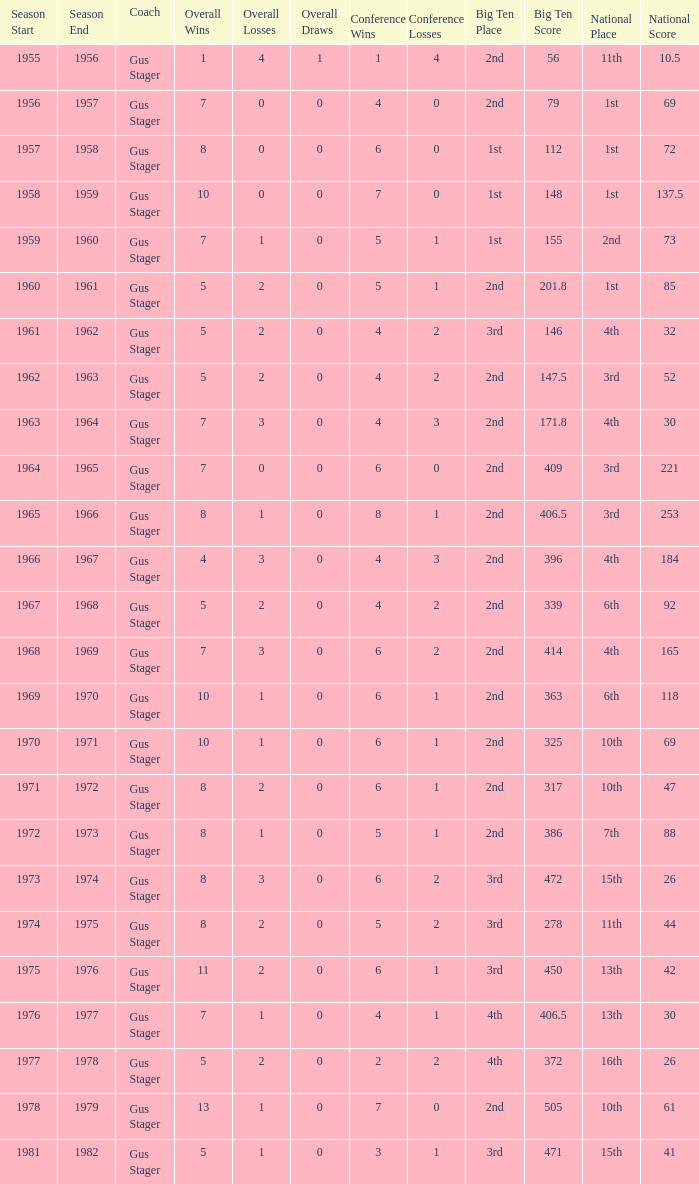What is the Coach with a Big Ten that is 3rd (278)? Gus Stager. 